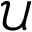<formula> <loc_0><loc_0><loc_500><loc_500>\mathcal { U }</formula> 